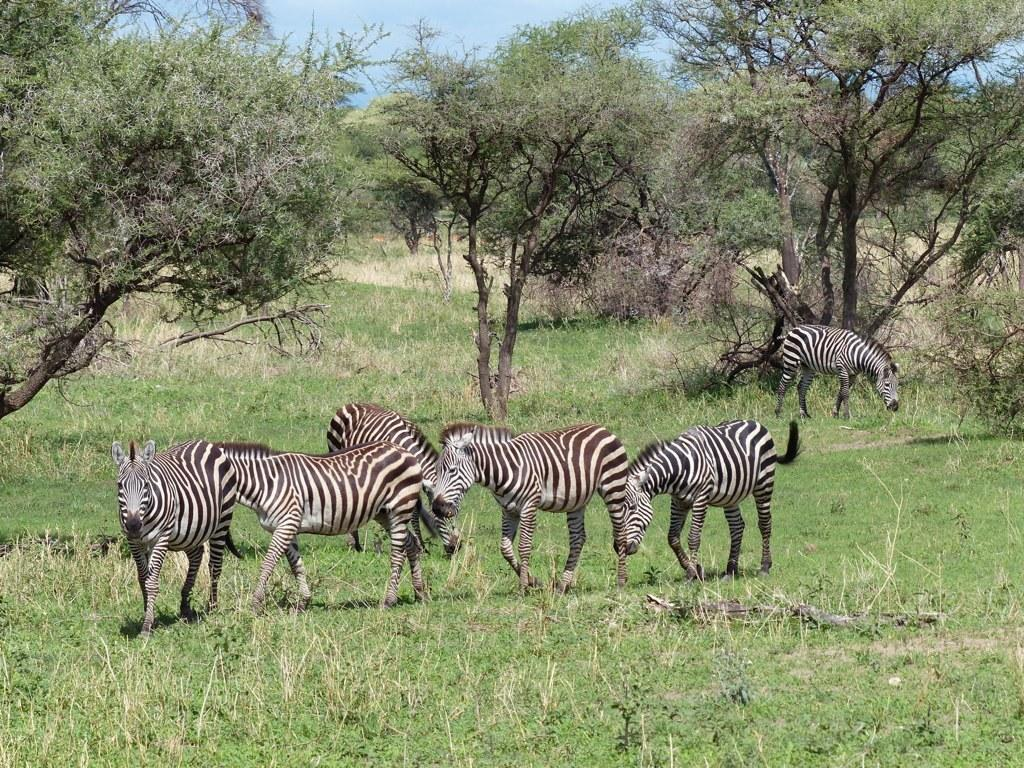What animals can be seen in the image? There are zebras in the image. What is the position of the zebras in the image? The zebras are standing on the ground. What type of vegetation covers the ground in the image? The ground is covered with grass, and dry plants are also present. What can be seen in the background of the image? There are trees in the background of the image. What is the condition of the sky in the image? The sky is clear in the image. What decision is the jar making in the image? There is no jar present in the image, so it cannot make any decisions. 